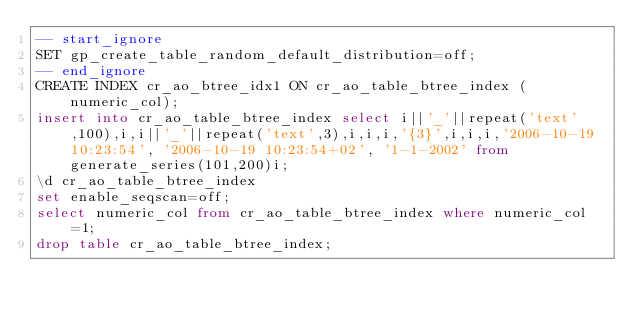<code> <loc_0><loc_0><loc_500><loc_500><_SQL_>-- start_ignore
SET gp_create_table_random_default_distribution=off;
-- end_ignore
CREATE INDEX cr_ao_btree_idx1 ON cr_ao_table_btree_index (numeric_col);
insert into cr_ao_table_btree_index select i||'_'||repeat('text',100),i,i||'_'||repeat('text',3),i,i,i,'{3}',i,i,i,'2006-10-19 10:23:54', '2006-10-19 10:23:54+02', '1-1-2002' from generate_series(101,200)i;
\d cr_ao_table_btree_index
set enable_seqscan=off;
select numeric_col from cr_ao_table_btree_index where numeric_col=1;
drop table cr_ao_table_btree_index;
</code> 